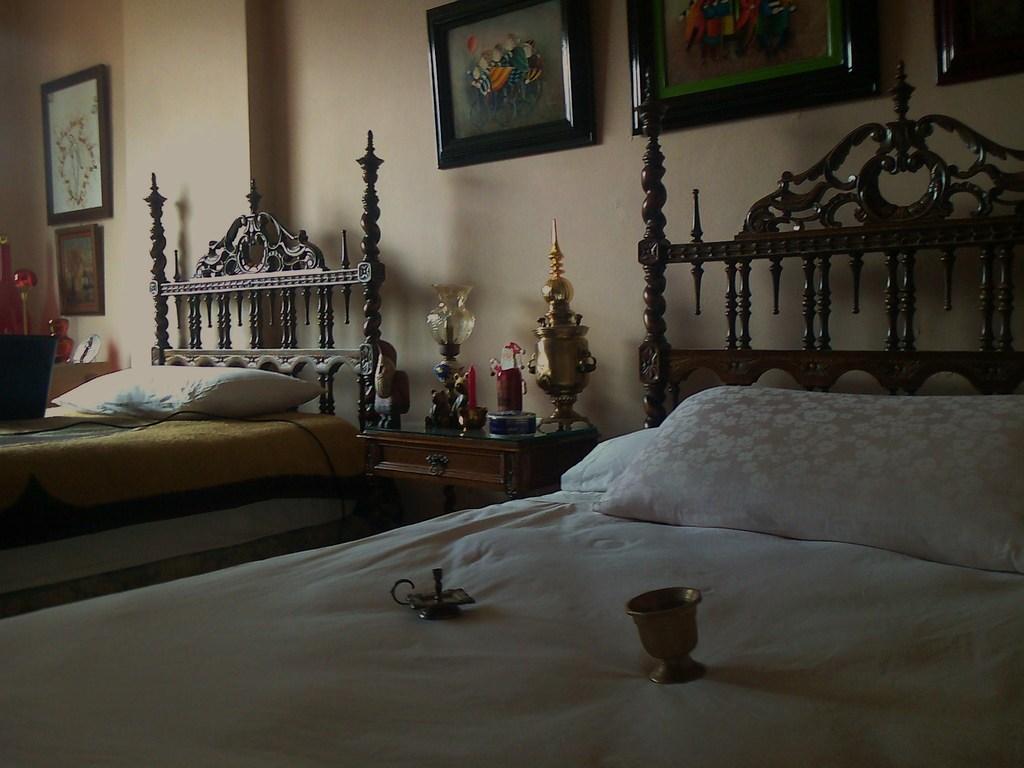In one or two sentences, can you explain what this image depicts? This picture is taken in a room. Towards the left, there are two beds with pillows. In the middle of the beds, there is a table. On the table, there are lamps and other show pieces. At the bottom, there are two objects placed on the beds. On the top, there is a wall with frames. 